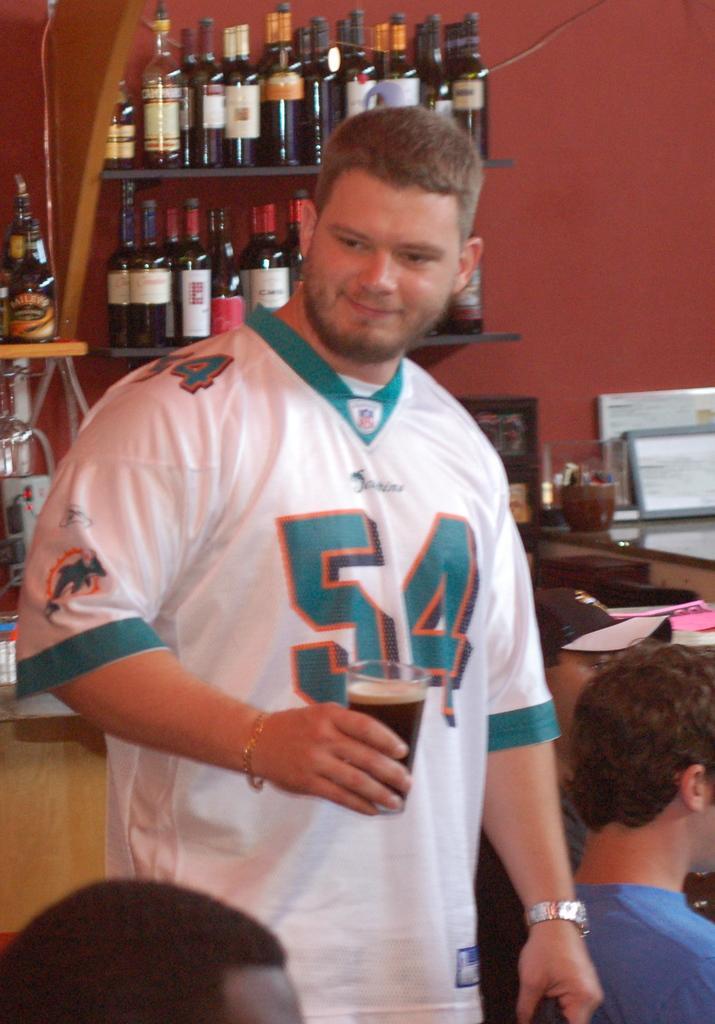Describe this image in one or two sentences. In this image we can see a person holding a glass with some drink, around him we can also see a few people. Behind the person we can see a few bottles on the shelves. 